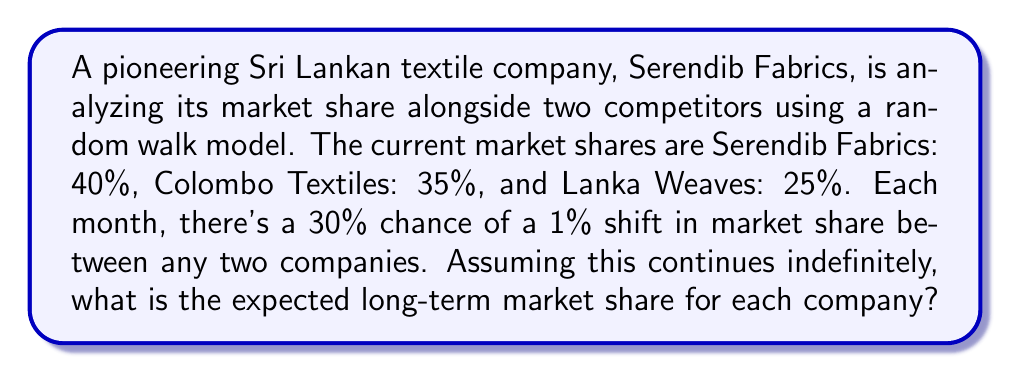Can you solve this math problem? To solve this problem, we'll use the properties of random walks and Markov chains:

1) In a random walk model with multiple states, the long-term probabilities converge to a stationary distribution.

2) For a symmetric random walk (equal probability of moving in either direction), the stationary distribution is uniform.

3) In this case, we have a symmetric situation:
   - Each company has an equal chance of gaining or losing market share.
   - The probability of change is the same for all companies.

4) Therefore, regardless of the starting positions, the long-term market shares will converge to an equal distribution among the three companies.

5) Mathematically, let $\pi_i$ be the long-term market share of company $i$. We have:

   $$\pi_1 + \pi_2 + \pi_3 = 1$$

   $$\pi_1 = \pi_2 = \pi_3$$

6) Solving these equations:

   $$3\pi_1 = 1$$
   $$\pi_1 = \frac{1}{3}$$

7) Therefore, each company's expected long-term market share is $\frac{1}{3}$ or approximately 33.33%.
Answer: 33.33% for each company 